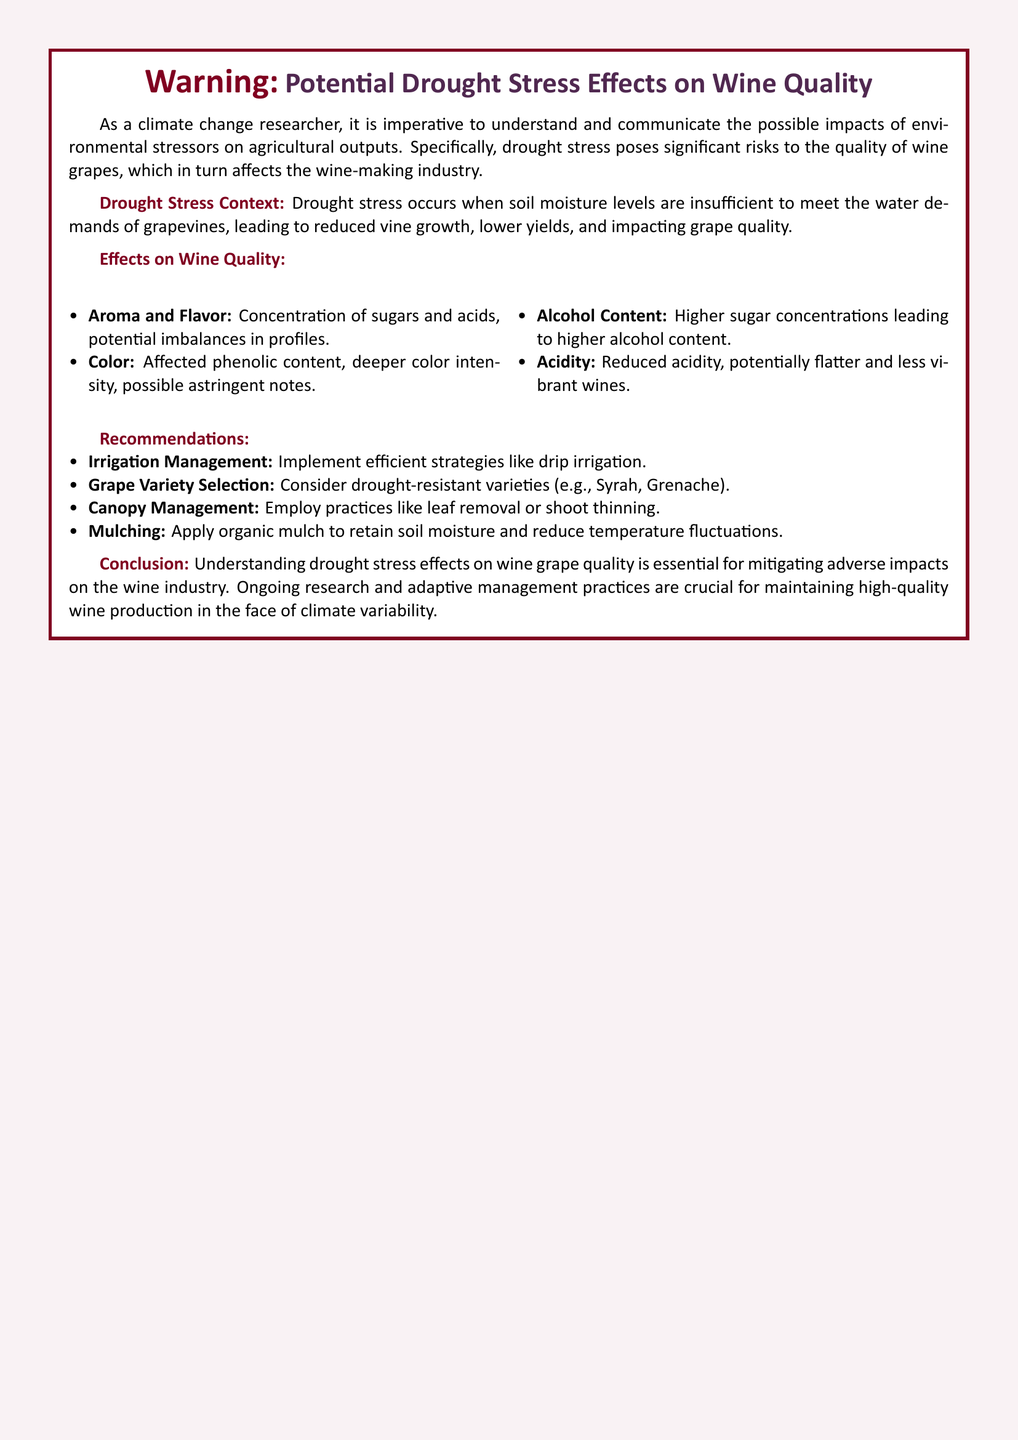What is the main focus of this warning label? The warning label primarily addresses the potential impacts of drought stress on wine quality.
Answer: Drought stress effects on wine quality What is one recommended irrigation management strategy? The document suggests implementing efficient strategies like drip irrigation.
Answer: Drip irrigation Name a grape variety recommended for drought resistance. The label mentions considering varieties such as Syrah and Grenache.
Answer: Syrah What is one effect of drought stress on wine aroma? Drought stress can lead to a concentration of sugars and acids, affecting aroma.
Answer: Concentration of sugars and acids How does drought stress affect wine acidity? The document states that drought stress can lead to reduced acidity in wine.
Answer: Reduced acidity What is the purpose of mulching according to the document? Mulching is recommended to retain soil moisture and reduce temperature fluctuations.
Answer: Retain soil moisture What color aspect can be affected by drought stress? The label indicates that drought stress affects phenolic content and color intensity.
Answer: Phenolic content and color intensity What does the conclusion emphasize regarding ongoing management practices? The conclusion stresses the importance of adaptive management practices for maintaining wine quality.
Answer: Adaptive management practices What color is predominantly used for the warning text? The text uses a color defined as winered for highlighting warnings.
Answer: Winered 